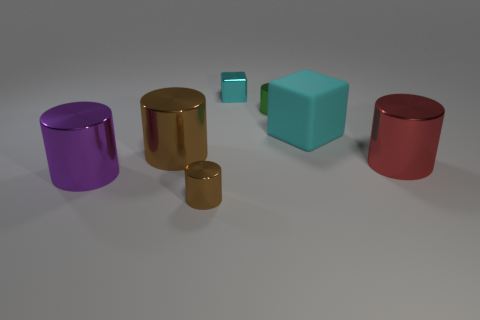Subtract 1 cylinders. How many cylinders are left? 4 Subtract all gray cylinders. Subtract all purple blocks. How many cylinders are left? 5 Add 2 small gray cubes. How many objects exist? 9 Subtract all cylinders. How many objects are left? 2 Subtract 0 purple balls. How many objects are left? 7 Subtract all small cyan matte cylinders. Subtract all small things. How many objects are left? 4 Add 6 red objects. How many red objects are left? 7 Add 3 cyan rubber spheres. How many cyan rubber spheres exist? 3 